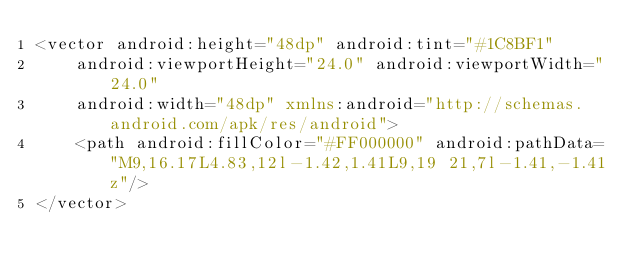<code> <loc_0><loc_0><loc_500><loc_500><_XML_><vector android:height="48dp" android:tint="#1C8BF1"
    android:viewportHeight="24.0" android:viewportWidth="24.0"
    android:width="48dp" xmlns:android="http://schemas.android.com/apk/res/android">
    <path android:fillColor="#FF000000" android:pathData="M9,16.17L4.83,12l-1.42,1.41L9,19 21,7l-1.41,-1.41z"/>
</vector>
</code> 